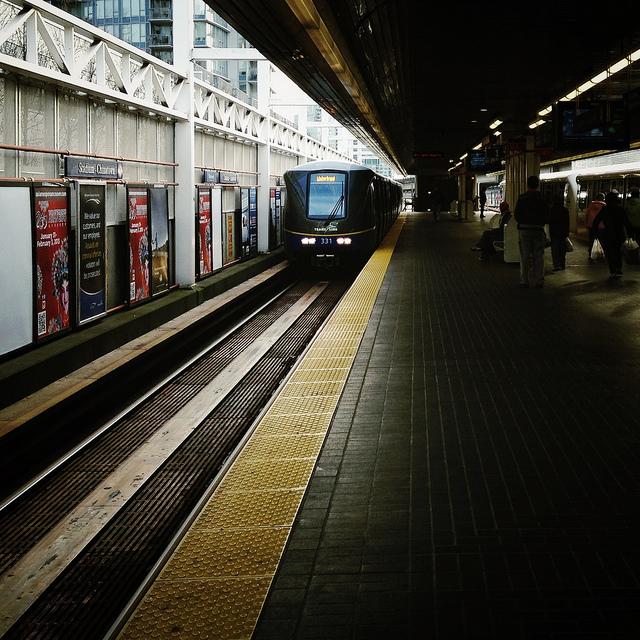Where is the train?
Write a very short answer. On tracks. Is this a train station?
Short answer required. Yes. How many tracks are there?
Write a very short answer. 1. Why the train didn't stop?
Write a very short answer. No passengers. 